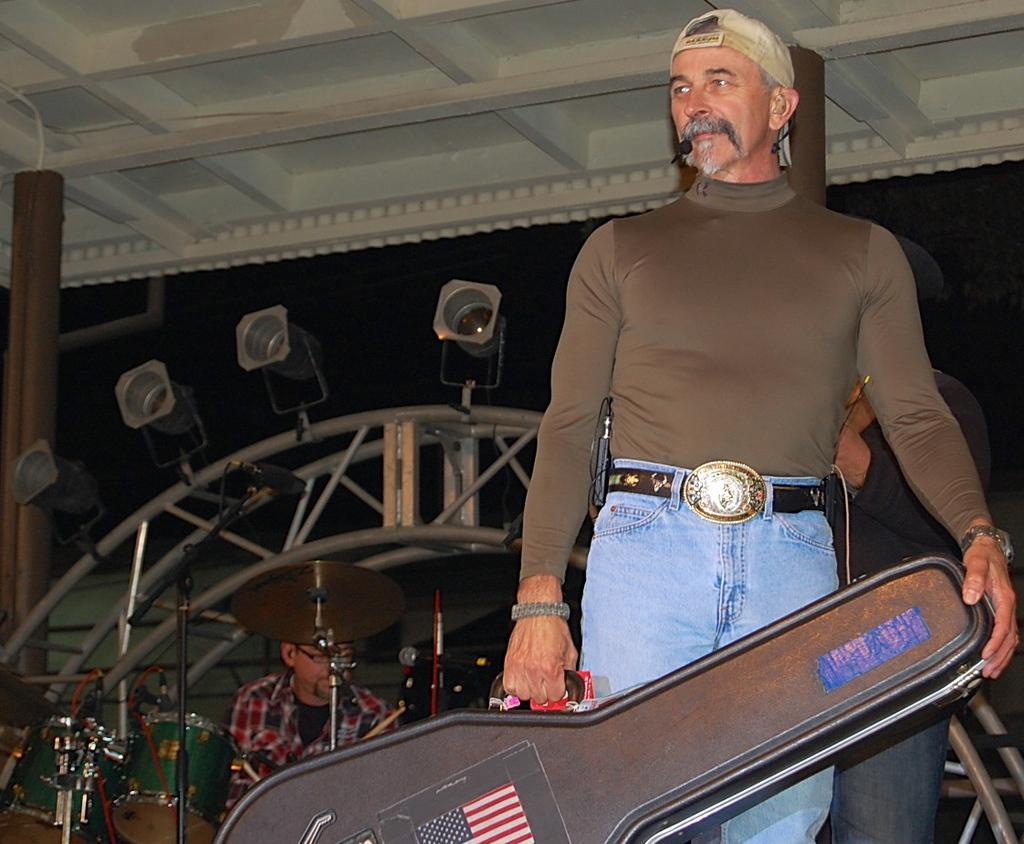Could you give a brief overview of what you see in this image? In this picture we can observe a man standing, holding a guitar box in his hand. He is wearing brown color T shirt and a cap on his head. In the background there is another person sitting in front of the drums. On the left side there is a brown color pole. 